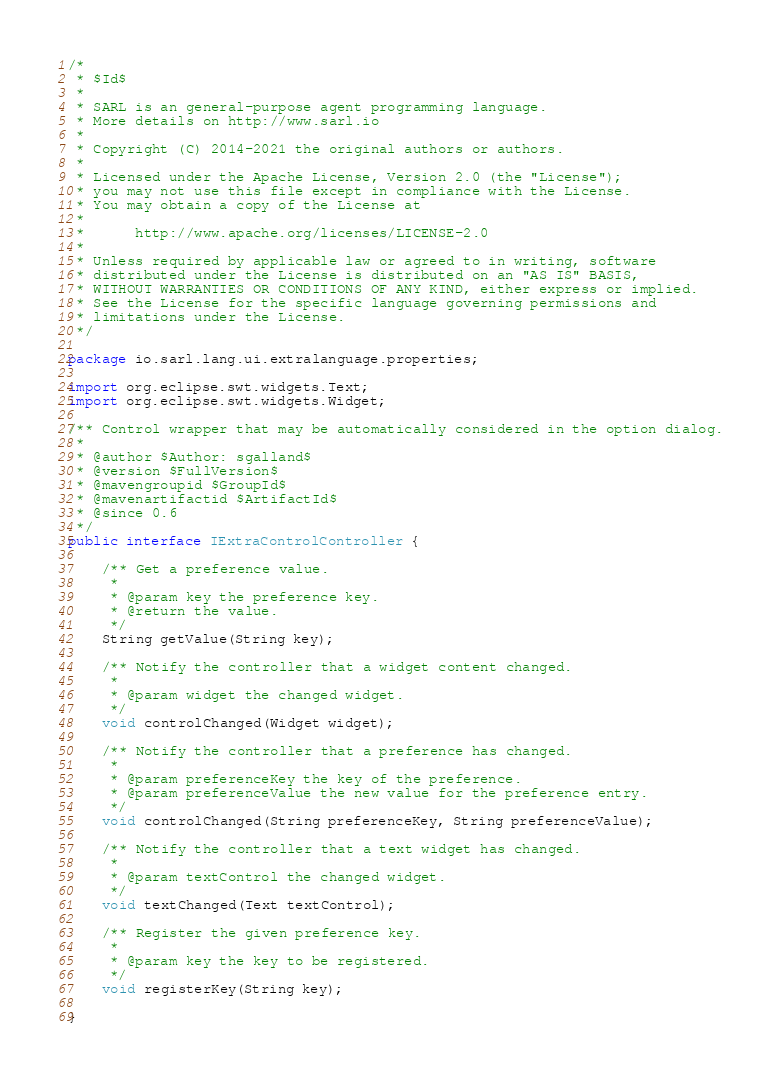Convert code to text. <code><loc_0><loc_0><loc_500><loc_500><_Java_>/*
 * $Id$
 *
 * SARL is an general-purpose agent programming language.
 * More details on http://www.sarl.io
 *
 * Copyright (C) 2014-2021 the original authors or authors.
 *
 * Licensed under the Apache License, Version 2.0 (the "License");
 * you may not use this file except in compliance with the License.
 * You may obtain a copy of the License at
 *
 *      http://www.apache.org/licenses/LICENSE-2.0
 *
 * Unless required by applicable law or agreed to in writing, software
 * distributed under the License is distributed on an "AS IS" BASIS,
 * WITHOUT WARRANTIES OR CONDITIONS OF ANY KIND, either express or implied.
 * See the License for the specific language governing permissions and
 * limitations under the License.
 */

package io.sarl.lang.ui.extralanguage.properties;

import org.eclipse.swt.widgets.Text;
import org.eclipse.swt.widgets.Widget;

/** Control wrapper that may be automatically considered in the option dialog.
 *
 * @author $Author: sgalland$
 * @version $FullVersion$
 * @mavengroupid $GroupId$
 * @mavenartifactid $ArtifactId$
 * @since 0.6
 */
public interface IExtraControlController {

	/** Get a preference value.
	 *
	 * @param key the preference key.
	 * @return the value.
	 */
	String getValue(String key);

	/** Notify the controller that a widget content changed.
	 *
	 * @param widget the changed widget.
	 */
	void controlChanged(Widget widget);

	/** Notify the controller that a preference has changed.
	 *
	 * @param preferenceKey the key of the preference.
	 * @param preferenceValue the new value for the preference entry.
	 */
	void controlChanged(String preferenceKey, String preferenceValue);

	/** Notify the controller that a text widget has changed.
	 *
	 * @param textControl the changed widget.
	 */
	void textChanged(Text textControl);

	/** Register the given preference key.
	 *
	 * @param key the key to be registered.
	 */
	void registerKey(String key);

}
</code> 